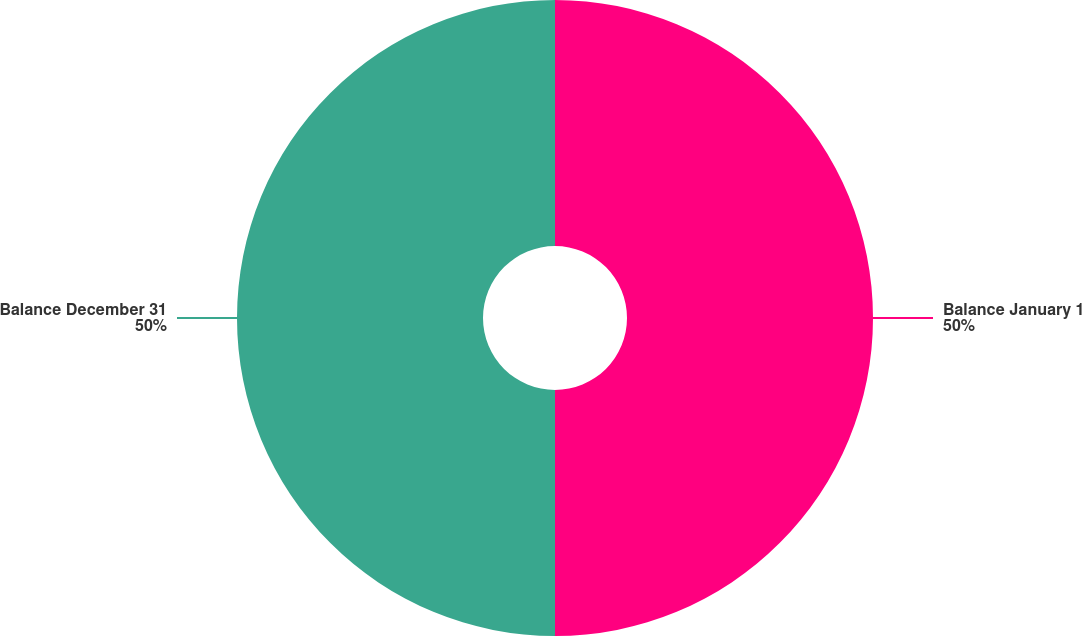<chart> <loc_0><loc_0><loc_500><loc_500><pie_chart><fcel>Balance January 1<fcel>Balance December 31<nl><fcel>50.0%<fcel>50.0%<nl></chart> 